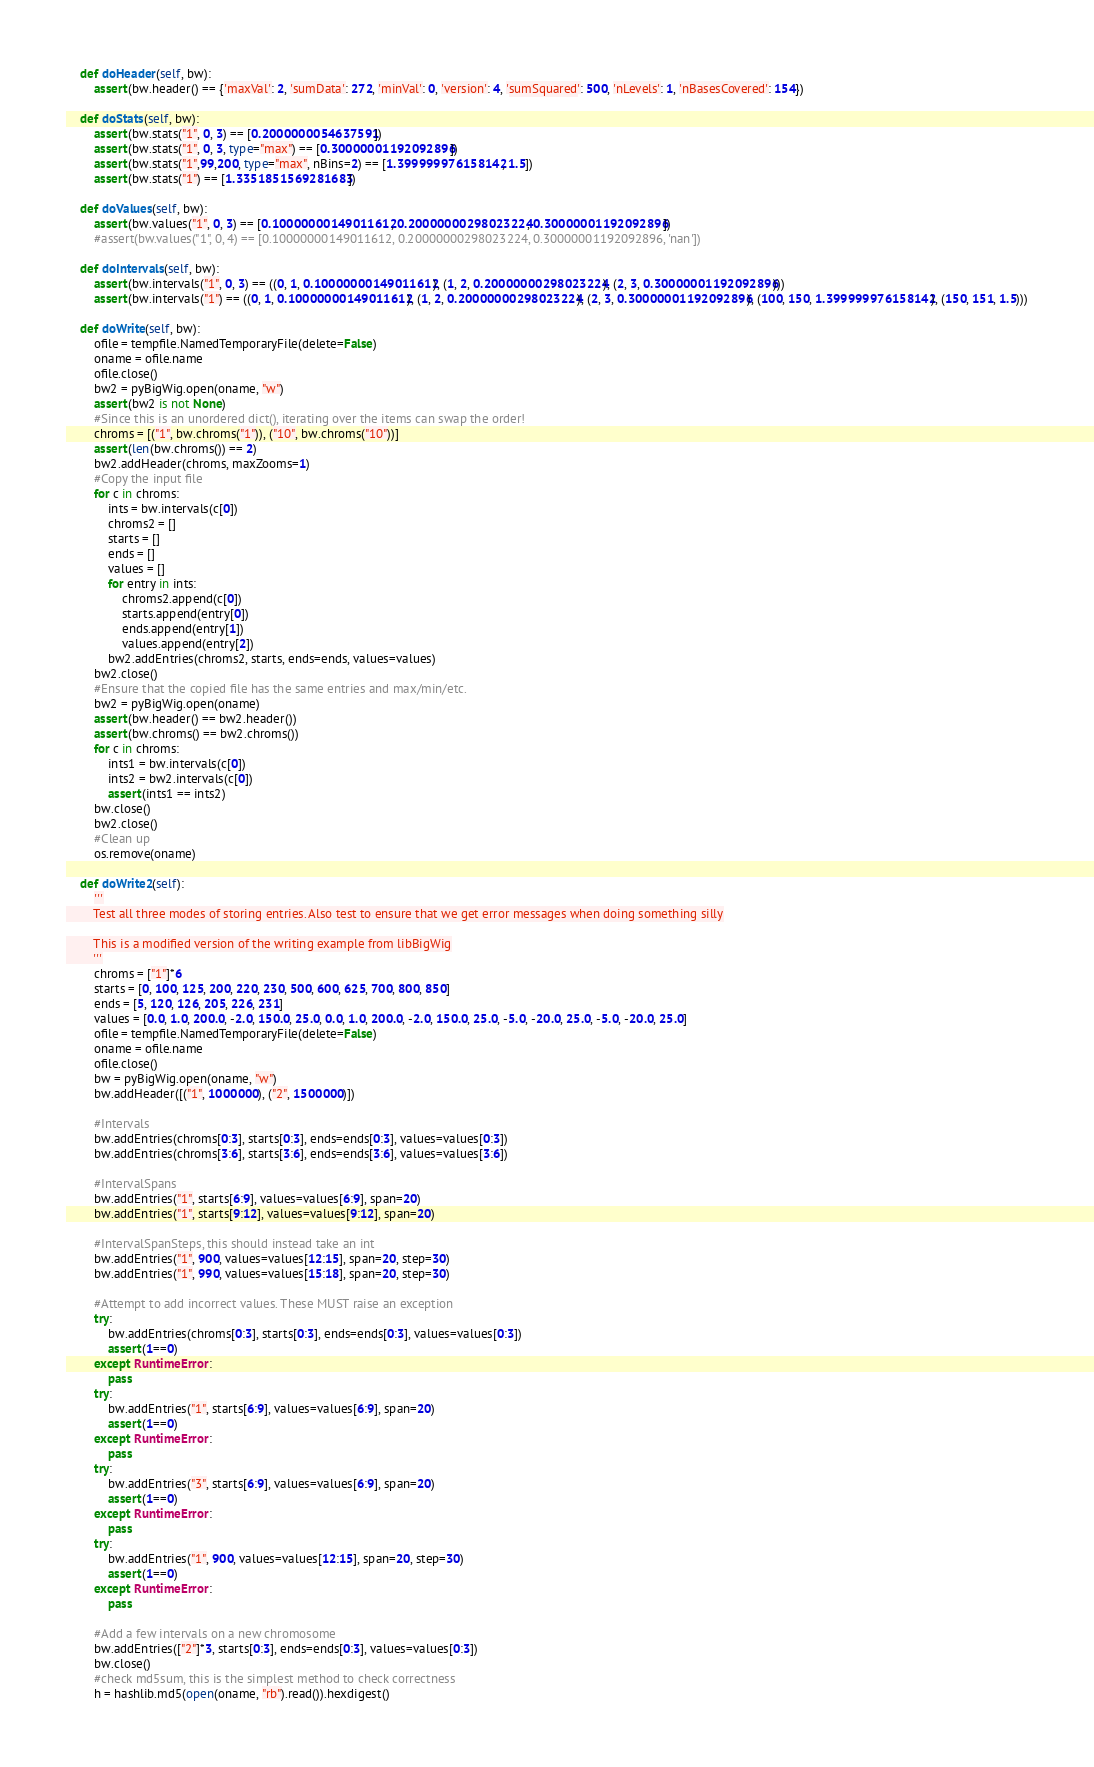Convert code to text. <code><loc_0><loc_0><loc_500><loc_500><_Python_>
    def doHeader(self, bw):
        assert(bw.header() == {'maxVal': 2, 'sumData': 272, 'minVal': 0, 'version': 4, 'sumSquared': 500, 'nLevels': 1, 'nBasesCovered': 154})

    def doStats(self, bw):
        assert(bw.stats("1", 0, 3) == [0.2000000054637591])
        assert(bw.stats("1", 0, 3, type="max") == [0.30000001192092896])
        assert(bw.stats("1",99,200, type="max", nBins=2) == [1.399999976158142, 1.5])
        assert(bw.stats("1") == [1.3351851569281683])

    def doValues(self, bw):
        assert(bw.values("1", 0, 3) == [0.10000000149011612, 0.20000000298023224, 0.30000001192092896])
        #assert(bw.values("1", 0, 4) == [0.10000000149011612, 0.20000000298023224, 0.30000001192092896, 'nan'])

    def doIntervals(self, bw):
        assert(bw.intervals("1", 0, 3) == ((0, 1, 0.10000000149011612), (1, 2, 0.20000000298023224), (2, 3, 0.30000001192092896)))
        assert(bw.intervals("1") == ((0, 1, 0.10000000149011612), (1, 2, 0.20000000298023224), (2, 3, 0.30000001192092896), (100, 150, 1.399999976158142), (150, 151, 1.5)))

    def doWrite(self, bw):
        ofile = tempfile.NamedTemporaryFile(delete=False)
        oname = ofile.name
        ofile.close()
        bw2 = pyBigWig.open(oname, "w")
        assert(bw2 is not None)
        #Since this is an unordered dict(), iterating over the items can swap the order!
        chroms = [("1", bw.chroms("1")), ("10", bw.chroms("10"))]
        assert(len(bw.chroms()) == 2)
        bw2.addHeader(chroms, maxZooms=1)
        #Copy the input file
        for c in chroms:
            ints = bw.intervals(c[0])
            chroms2 = []
            starts = []
            ends = []
            values = []
            for entry in ints:
                chroms2.append(c[0])
                starts.append(entry[0])
                ends.append(entry[1])
                values.append(entry[2])
            bw2.addEntries(chroms2, starts, ends=ends, values=values)
        bw2.close()
        #Ensure that the copied file has the same entries and max/min/etc.
        bw2 = pyBigWig.open(oname)
        assert(bw.header() == bw2.header())
        assert(bw.chroms() == bw2.chroms())
        for c in chroms:
            ints1 = bw.intervals(c[0])
            ints2 = bw2.intervals(c[0])
            assert(ints1 == ints2)
        bw.close()
        bw2.close()
        #Clean up
        os.remove(oname)

    def doWrite2(self):
        '''
        Test all three modes of storing entries. Also test to ensure that we get error messages when doing something silly

        This is a modified version of the writing example from libBigWig
        '''
        chroms = ["1"]*6
        starts = [0, 100, 125, 200, 220, 230, 500, 600, 625, 700, 800, 850]
        ends = [5, 120, 126, 205, 226, 231]
        values = [0.0, 1.0, 200.0, -2.0, 150.0, 25.0, 0.0, 1.0, 200.0, -2.0, 150.0, 25.0, -5.0, -20.0, 25.0, -5.0, -20.0, 25.0]
        ofile = tempfile.NamedTemporaryFile(delete=False)
        oname = ofile.name
        ofile.close()
        bw = pyBigWig.open(oname, "w")
        bw.addHeader([("1", 1000000), ("2", 1500000)])

        #Intervals
        bw.addEntries(chroms[0:3], starts[0:3], ends=ends[0:3], values=values[0:3])
        bw.addEntries(chroms[3:6], starts[3:6], ends=ends[3:6], values=values[3:6])

        #IntervalSpans
        bw.addEntries("1", starts[6:9], values=values[6:9], span=20)
        bw.addEntries("1", starts[9:12], values=values[9:12], span=20)

        #IntervalSpanSteps, this should instead take an int
        bw.addEntries("1", 900, values=values[12:15], span=20, step=30)
        bw.addEntries("1", 990, values=values[15:18], span=20, step=30)

        #Attempt to add incorrect values. These MUST raise an exception
        try:
            bw.addEntries(chroms[0:3], starts[0:3], ends=ends[0:3], values=values[0:3])
            assert(1==0)
        except RuntimeError:
            pass
        try:
            bw.addEntries("1", starts[6:9], values=values[6:9], span=20)
            assert(1==0)
        except RuntimeError:
            pass
        try:
            bw.addEntries("3", starts[6:9], values=values[6:9], span=20)
            assert(1==0)
        except RuntimeError:
            pass
        try:
            bw.addEntries("1", 900, values=values[12:15], span=20, step=30)
            assert(1==0)
        except RuntimeError:
            pass

        #Add a few intervals on a new chromosome
        bw.addEntries(["2"]*3, starts[0:3], ends=ends[0:3], values=values[0:3])
        bw.close()
        #check md5sum, this is the simplest method to check correctness
        h = hashlib.md5(open(oname, "rb").read()).hexdigest()</code> 